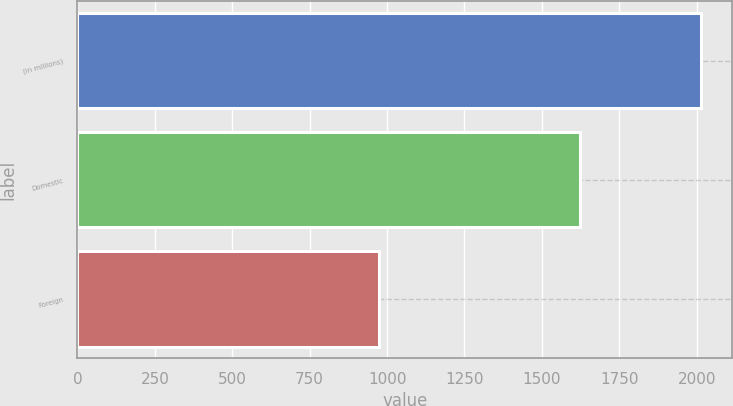Convert chart to OTSL. <chart><loc_0><loc_0><loc_500><loc_500><bar_chart><fcel>(in millions)<fcel>Domestic<fcel>Foreign<nl><fcel>2015<fcel>1623<fcel>973<nl></chart> 